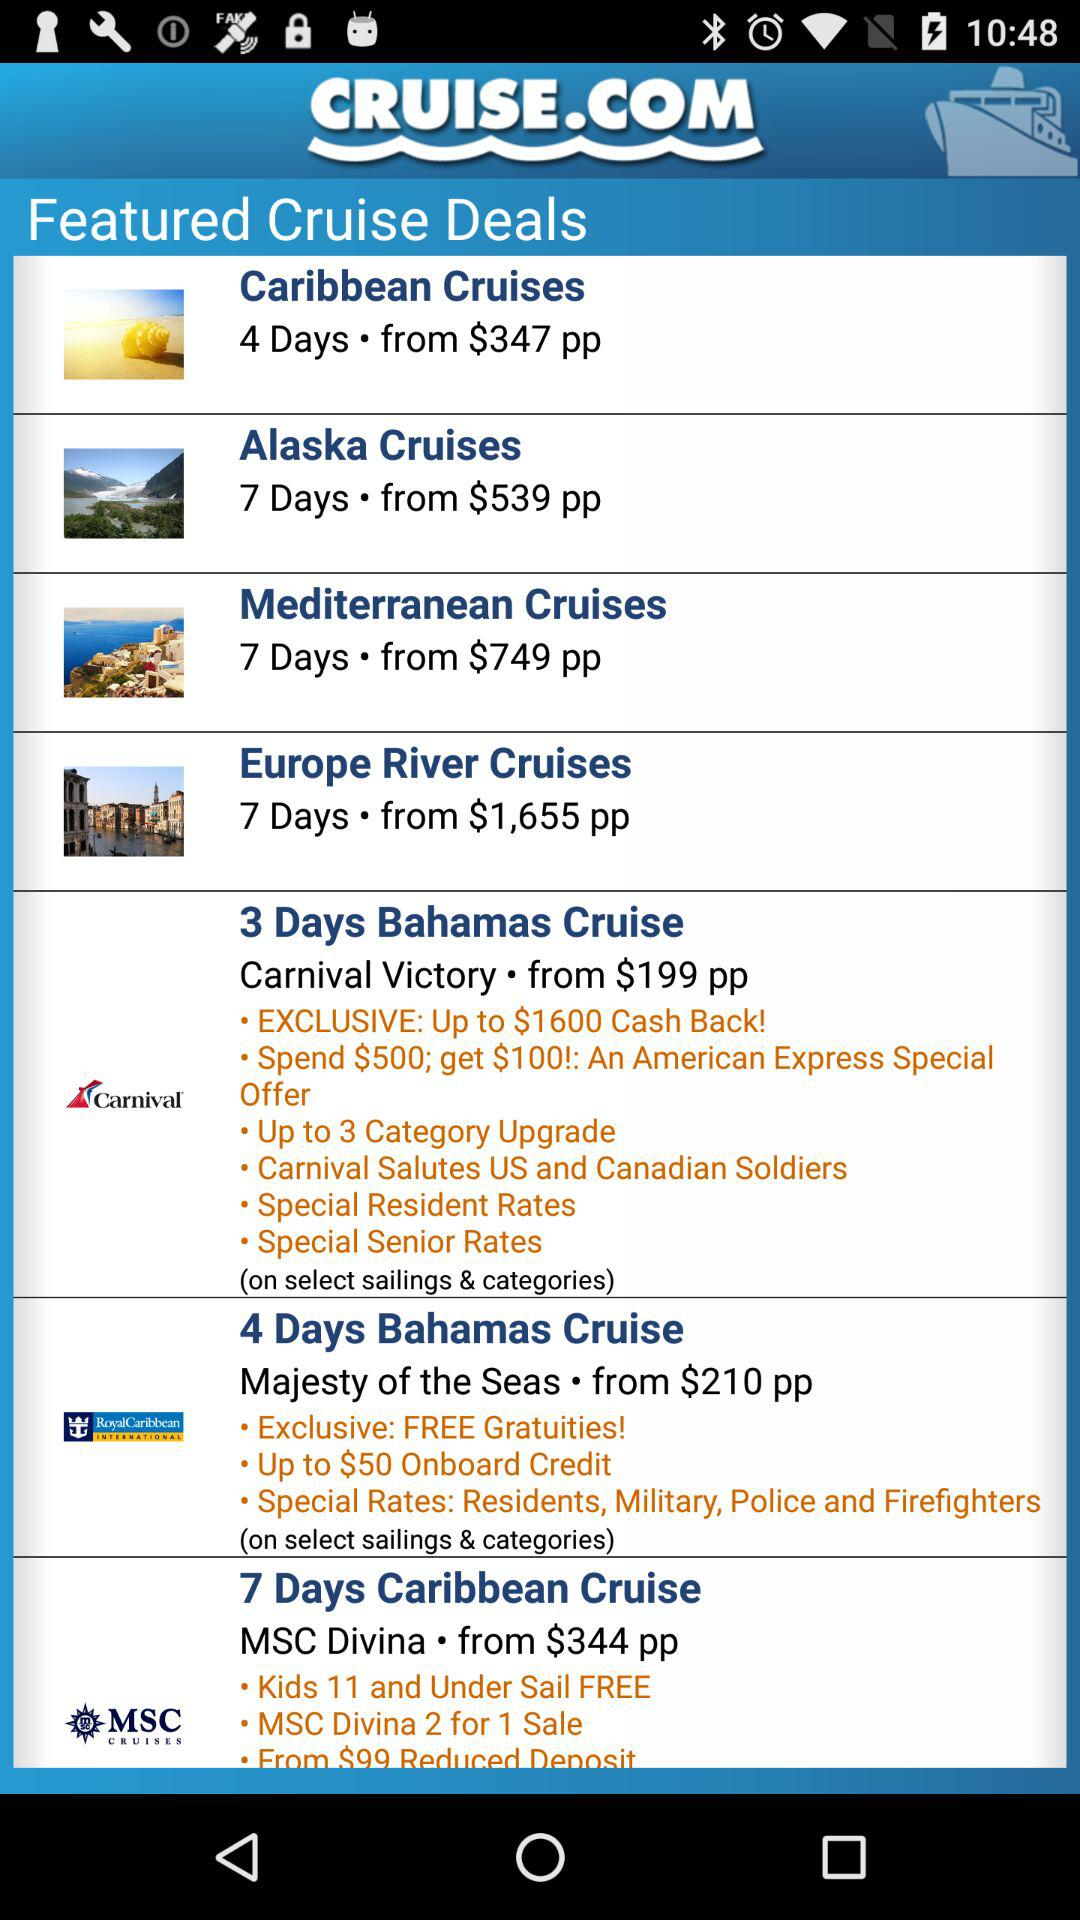What is the starting price of the "7 Days Caribbean Cruise"? The starting price of the "7 Days Caribbean Cruise" is $344 per person. 